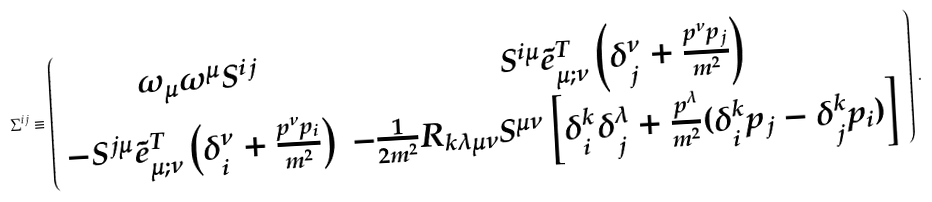Convert formula to latex. <formula><loc_0><loc_0><loc_500><loc_500>\Sigma ^ { i j } \equiv \left ( \begin{array} { c c } \omega _ { \mu } \omega ^ { \mu } S ^ { i j } & { S ^ { i \mu } } \tilde { e } ^ { T } _ { \mu ; \nu } \left ( \delta ^ { \nu } _ { j } + \frac { p ^ { \nu } p _ { j } } { m ^ { 2 } } \right ) \\ - { S ^ { j \mu } } \tilde { e } ^ { T } _ { \mu ; \nu } \left ( \delta ^ { \nu } _ { i } + \frac { p ^ { \nu } p _ { i } } { m ^ { 2 } } \right ) & - \frac { 1 } { 2 m ^ { 2 } } R _ { k \lambda \mu \nu } S ^ { \mu \nu } \left [ \delta ^ { k } _ { i } \delta ^ { \lambda } _ { j } + \frac { p ^ { \lambda } } { m ^ { 2 } } ( \delta ^ { k } _ { i } p _ { j } - \delta ^ { k } _ { j } p _ { i } ) \right ] \\ \end{array} \right ) \, .</formula> 